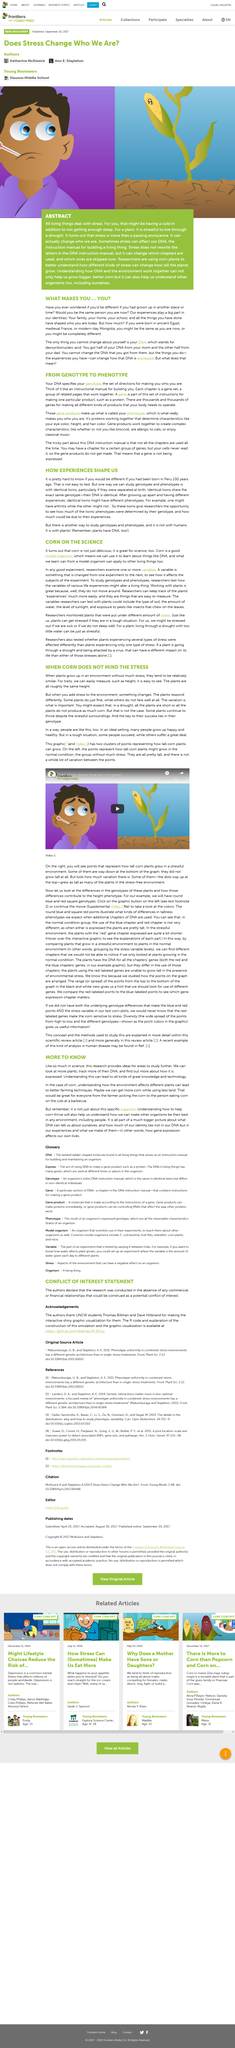Highlight a few significant elements in this photo. The genotype of plants that thrive despite their stressful surroundings is the key to their success. Plants experience stress in a similar manner to humans, with both being affected by factors such as a lack of sleep and a cold, as well as more extreme situations such as droughts for plants. Where are Thomas Billman and Dave Hiltbrand students? They are both UNCW students. The shiny graphic visualization for the authors was created by Thomas Billman and Dave Hiltbrand. Genotypes and phenotypes can be studied through the use of identical twins, as one way to understand the relationship between an individual's genetic makeup and their observable characteristics. 